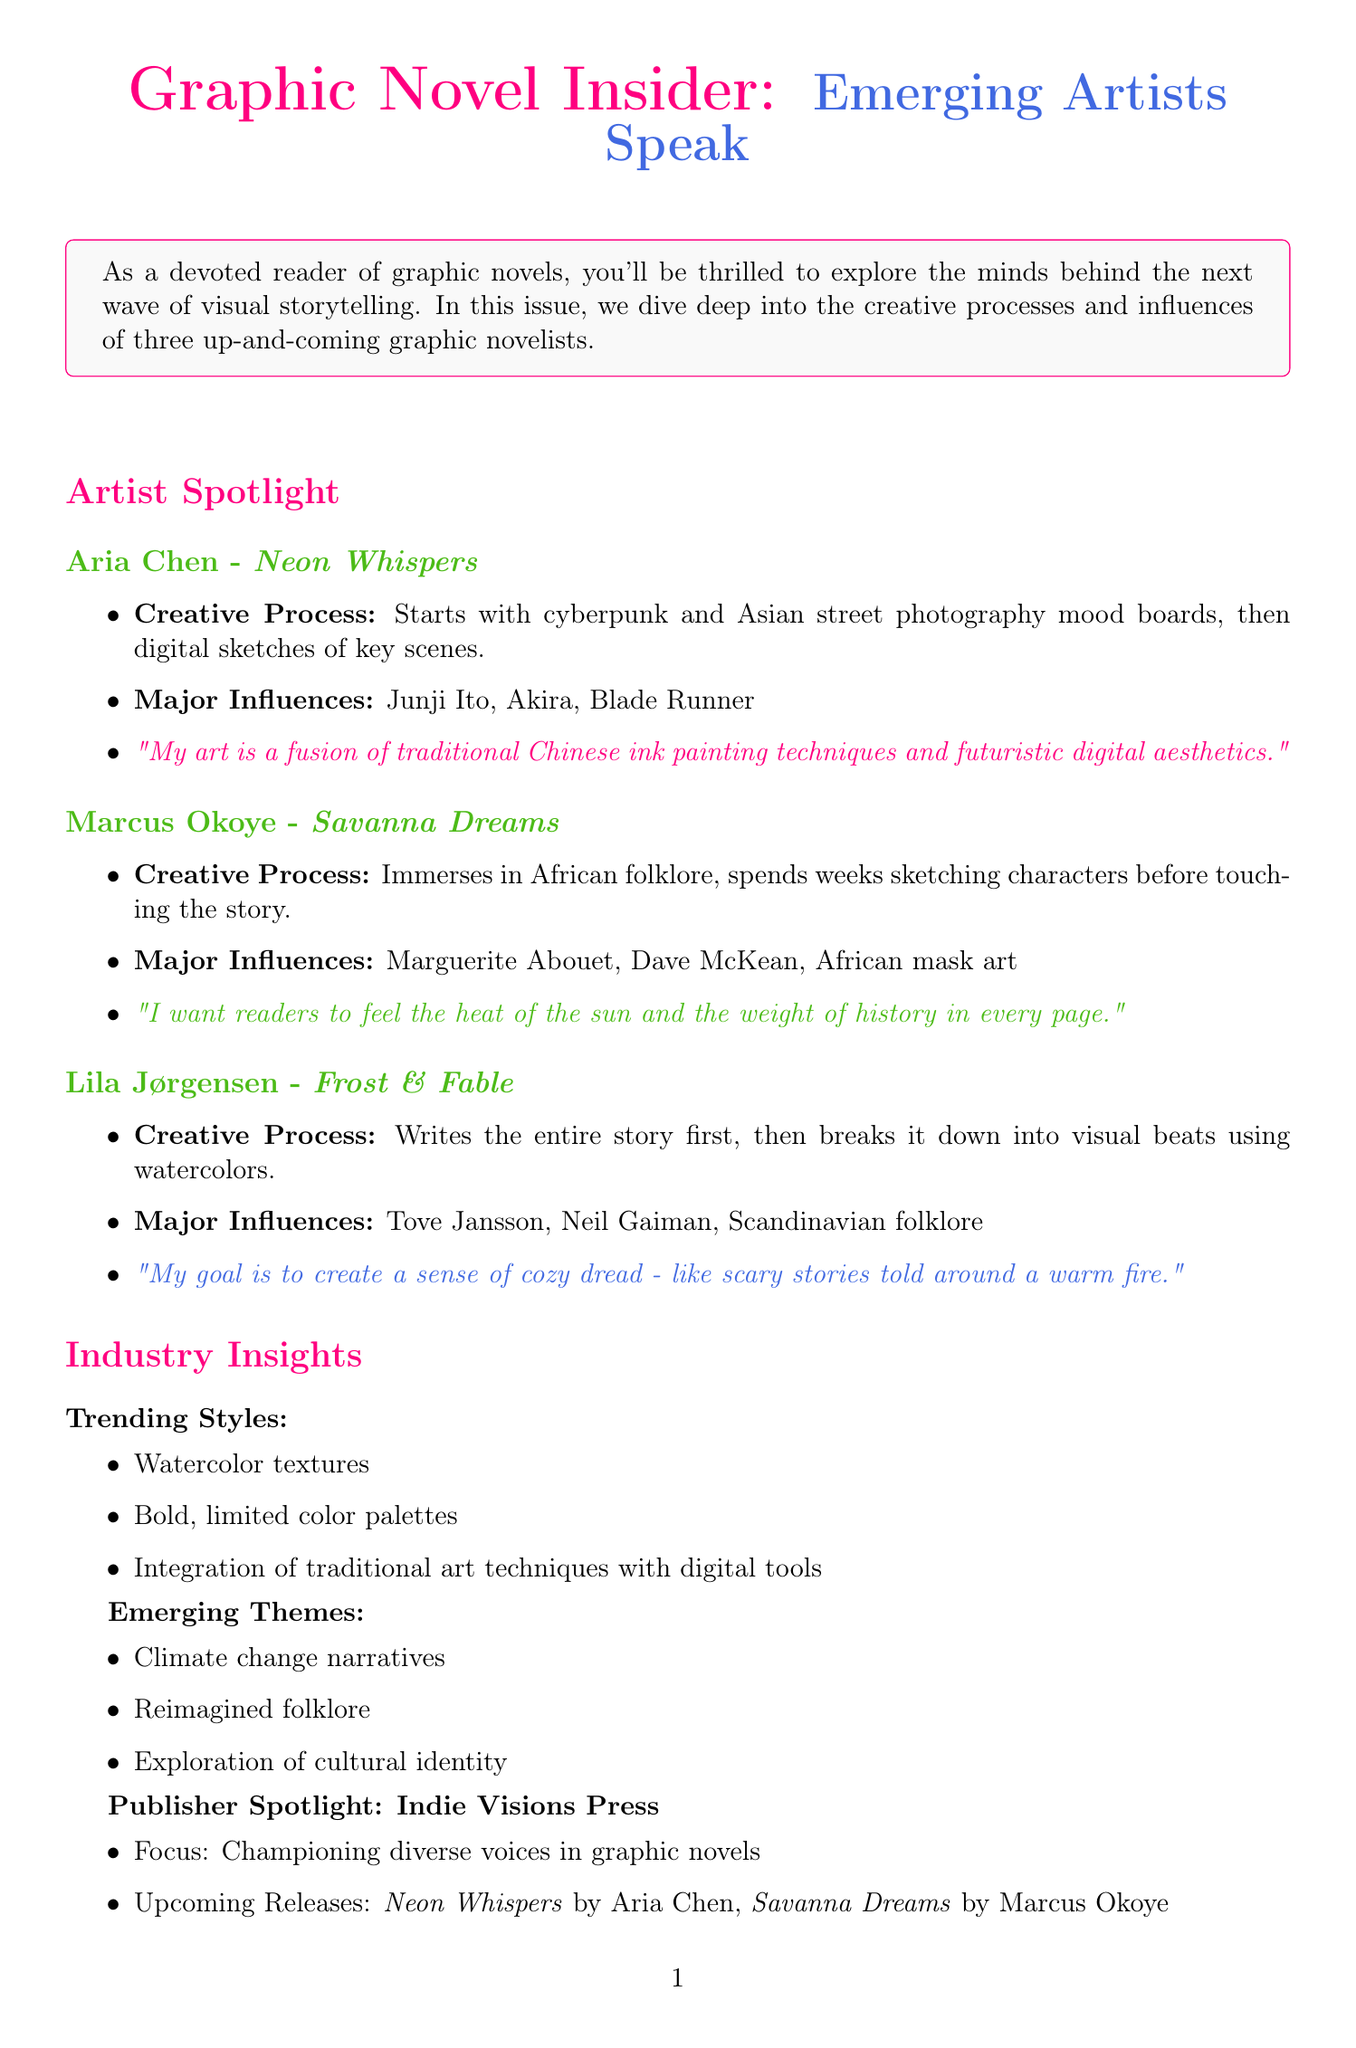What is the title of Aria Chen's upcoming novel? The title of Aria Chen's upcoming novel is mentioned as \textit{Neon Whispers}.
Answer: Neon Whispers Who are Marcus Okoye's major influences? Major influences for Marcus Okoye include Marguerite Abouet, Dave McKean, and African mask art.
Answer: Marguerite Abouet, Dave McKean, African mask art What unique artistic technique does Lila Jørgensen use for her artwork? Lila Jørgensen's unique artistic technique involves using watercolors for all her artwork.
Answer: Watercolors What is the focus of Indie Visions Press? The focus of Indie Visions Press is promoting diverse voices in graphic novels.
Answer: Championing diverse voices in graphic novels How long is the Graphic Novel Expo 2023? The duration of the Graphic Novel Expo 2023 is specified as September 15-17, 2023.
Answer: September 15-17, 2023 How does Marcus Okoye start his creative process? Marcus Okoye immerses himself in African folklore and spends weeks sketching characters before he begins storytelling.
Answer: Immerses in African folklore What is the book club pick for this issue? The book club pick highlighted in this issue is \textit{Frost \& Fable} by Lila Jørgensen.
Answer: Frost & Fable What upcoming event features a live drawing demonstration? The upcoming event featuring a live drawing demonstration by Marcus Okoye is the Indie Comics Festival.
Answer: Indie Comics Festival 